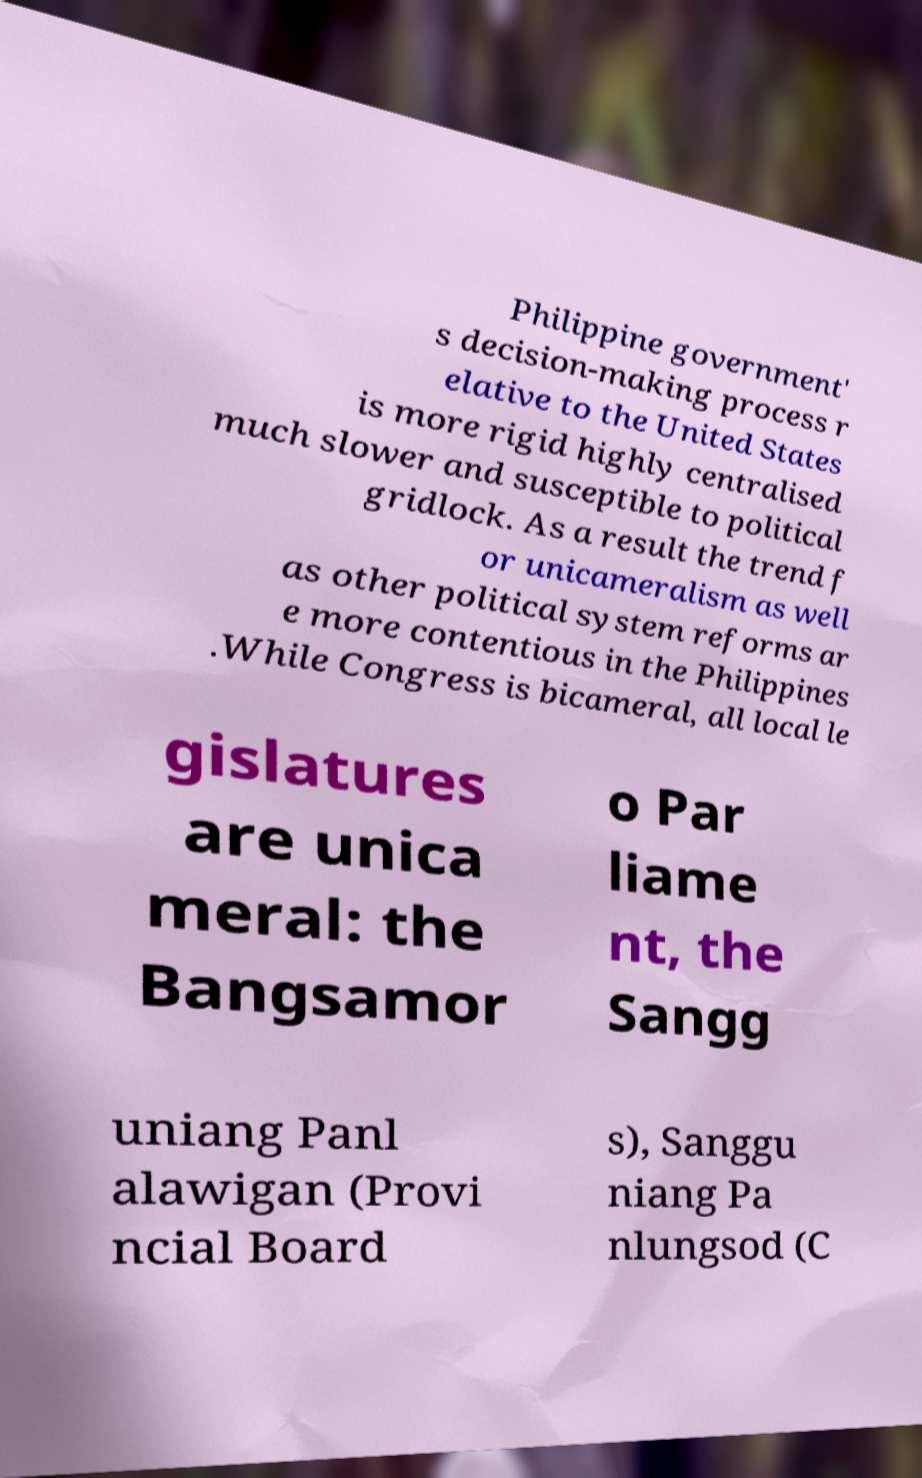Could you assist in decoding the text presented in this image and type it out clearly? Philippine government' s decision-making process r elative to the United States is more rigid highly centralised much slower and susceptible to political gridlock. As a result the trend f or unicameralism as well as other political system reforms ar e more contentious in the Philippines .While Congress is bicameral, all local le gislatures are unica meral: the Bangsamor o Par liame nt, the Sangg uniang Panl alawigan (Provi ncial Board s), Sanggu niang Pa nlungsod (C 